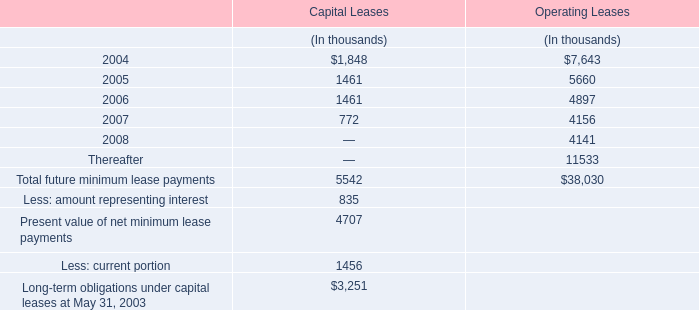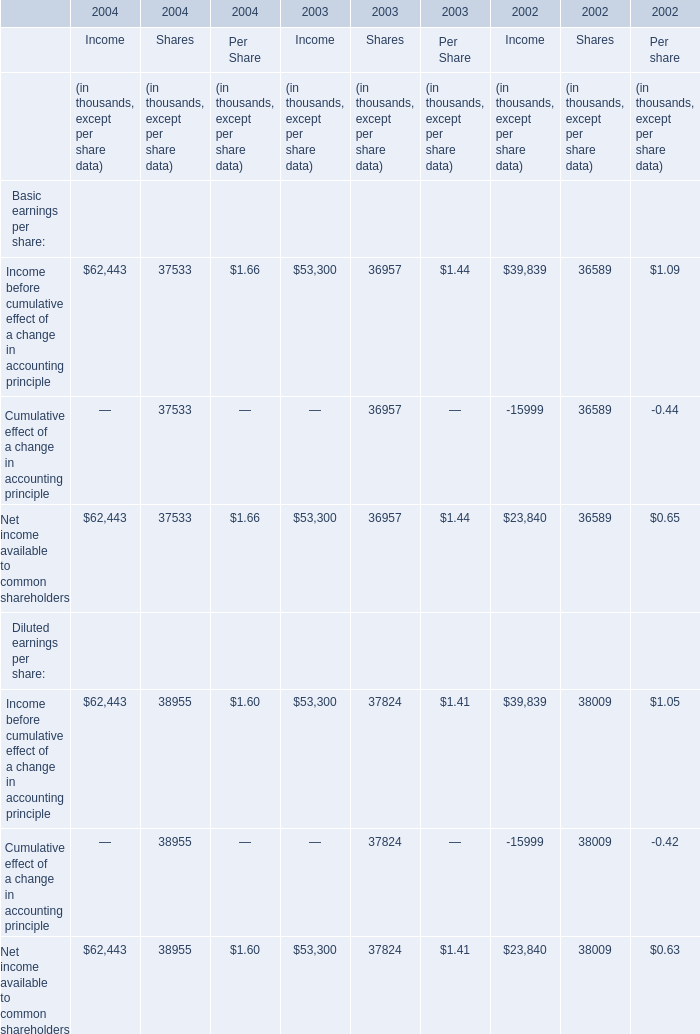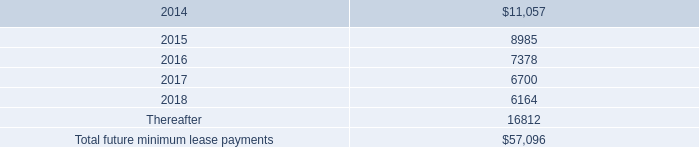What is the growing rate of Income before cumulative effect of a change in accounting principle in the years with the least Net income available to common shareholders for Shares? 
Computations: ((37824 - 38009) / 38009)
Answer: -0.00487. 